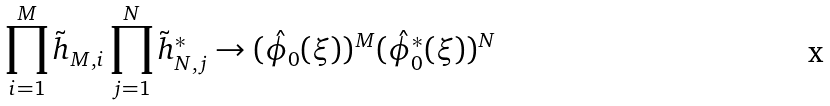Convert formula to latex. <formula><loc_0><loc_0><loc_500><loc_500>\prod _ { i = 1 } ^ { M } \tilde { h } _ { M , i } \prod _ { j = 1 } ^ { N } \tilde { h } _ { N , j } ^ { * } \to ( \hat { \phi } _ { 0 } ( \xi ) ) ^ { M } ( \hat { \phi } _ { 0 } ^ { * } ( \xi ) ) ^ { N }</formula> 